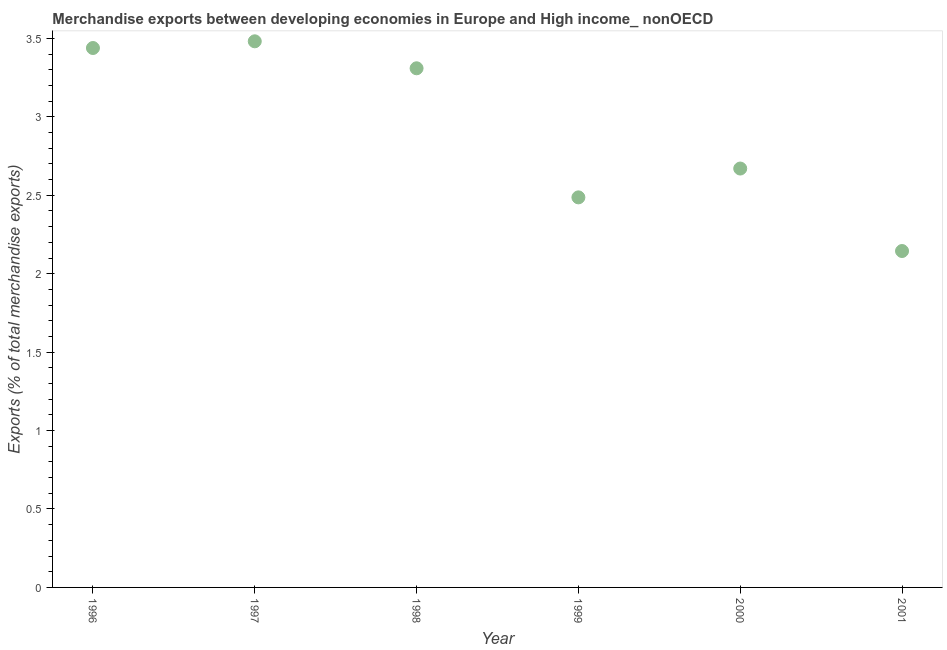What is the merchandise exports in 2000?
Offer a very short reply. 2.67. Across all years, what is the maximum merchandise exports?
Your answer should be compact. 3.48. Across all years, what is the minimum merchandise exports?
Provide a short and direct response. 2.14. What is the sum of the merchandise exports?
Ensure brevity in your answer.  17.53. What is the difference between the merchandise exports in 1999 and 2001?
Keep it short and to the point. 0.34. What is the average merchandise exports per year?
Offer a very short reply. 2.92. What is the median merchandise exports?
Your answer should be compact. 2.99. In how many years, is the merchandise exports greater than 3.1 %?
Offer a very short reply. 3. Do a majority of the years between 2001 and 1999 (inclusive) have merchandise exports greater than 1.9 %?
Provide a short and direct response. No. What is the ratio of the merchandise exports in 1996 to that in 1997?
Your answer should be compact. 0.99. Is the difference between the merchandise exports in 1996 and 2001 greater than the difference between any two years?
Offer a very short reply. No. What is the difference between the highest and the second highest merchandise exports?
Offer a terse response. 0.04. Is the sum of the merchandise exports in 1999 and 2001 greater than the maximum merchandise exports across all years?
Provide a succinct answer. Yes. What is the difference between the highest and the lowest merchandise exports?
Keep it short and to the point. 1.34. In how many years, is the merchandise exports greater than the average merchandise exports taken over all years?
Offer a terse response. 3. Does the merchandise exports monotonically increase over the years?
Keep it short and to the point. No. How many years are there in the graph?
Provide a short and direct response. 6. What is the difference between two consecutive major ticks on the Y-axis?
Keep it short and to the point. 0.5. Does the graph contain grids?
Your answer should be compact. No. What is the title of the graph?
Your answer should be compact. Merchandise exports between developing economies in Europe and High income_ nonOECD. What is the label or title of the Y-axis?
Give a very brief answer. Exports (% of total merchandise exports). What is the Exports (% of total merchandise exports) in 1996?
Your response must be concise. 3.44. What is the Exports (% of total merchandise exports) in 1997?
Your answer should be very brief. 3.48. What is the Exports (% of total merchandise exports) in 1998?
Your answer should be very brief. 3.31. What is the Exports (% of total merchandise exports) in 1999?
Your answer should be very brief. 2.49. What is the Exports (% of total merchandise exports) in 2000?
Your response must be concise. 2.67. What is the Exports (% of total merchandise exports) in 2001?
Provide a short and direct response. 2.14. What is the difference between the Exports (% of total merchandise exports) in 1996 and 1997?
Provide a short and direct response. -0.04. What is the difference between the Exports (% of total merchandise exports) in 1996 and 1998?
Your answer should be compact. 0.13. What is the difference between the Exports (% of total merchandise exports) in 1996 and 1999?
Give a very brief answer. 0.95. What is the difference between the Exports (% of total merchandise exports) in 1996 and 2000?
Keep it short and to the point. 0.77. What is the difference between the Exports (% of total merchandise exports) in 1996 and 2001?
Provide a short and direct response. 1.29. What is the difference between the Exports (% of total merchandise exports) in 1997 and 1998?
Your answer should be compact. 0.17. What is the difference between the Exports (% of total merchandise exports) in 1997 and 1999?
Your answer should be very brief. 0.99. What is the difference between the Exports (% of total merchandise exports) in 1997 and 2000?
Ensure brevity in your answer.  0.81. What is the difference between the Exports (% of total merchandise exports) in 1997 and 2001?
Offer a terse response. 1.34. What is the difference between the Exports (% of total merchandise exports) in 1998 and 1999?
Your answer should be very brief. 0.82. What is the difference between the Exports (% of total merchandise exports) in 1998 and 2000?
Offer a terse response. 0.64. What is the difference between the Exports (% of total merchandise exports) in 1998 and 2001?
Your answer should be compact. 1.16. What is the difference between the Exports (% of total merchandise exports) in 1999 and 2000?
Offer a very short reply. -0.18. What is the difference between the Exports (% of total merchandise exports) in 1999 and 2001?
Offer a terse response. 0.34. What is the difference between the Exports (% of total merchandise exports) in 2000 and 2001?
Offer a very short reply. 0.53. What is the ratio of the Exports (% of total merchandise exports) in 1996 to that in 1998?
Give a very brief answer. 1.04. What is the ratio of the Exports (% of total merchandise exports) in 1996 to that in 1999?
Make the answer very short. 1.38. What is the ratio of the Exports (% of total merchandise exports) in 1996 to that in 2000?
Give a very brief answer. 1.29. What is the ratio of the Exports (% of total merchandise exports) in 1996 to that in 2001?
Provide a short and direct response. 1.6. What is the ratio of the Exports (% of total merchandise exports) in 1997 to that in 1998?
Your response must be concise. 1.05. What is the ratio of the Exports (% of total merchandise exports) in 1997 to that in 2000?
Keep it short and to the point. 1.3. What is the ratio of the Exports (% of total merchandise exports) in 1997 to that in 2001?
Your response must be concise. 1.62. What is the ratio of the Exports (% of total merchandise exports) in 1998 to that in 1999?
Offer a very short reply. 1.33. What is the ratio of the Exports (% of total merchandise exports) in 1998 to that in 2000?
Offer a terse response. 1.24. What is the ratio of the Exports (% of total merchandise exports) in 1998 to that in 2001?
Your answer should be very brief. 1.54. What is the ratio of the Exports (% of total merchandise exports) in 1999 to that in 2001?
Your answer should be very brief. 1.16. What is the ratio of the Exports (% of total merchandise exports) in 2000 to that in 2001?
Keep it short and to the point. 1.25. 